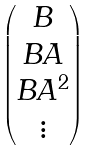Convert formula to latex. <formula><loc_0><loc_0><loc_500><loc_500>\begin{pmatrix} B \\ B A \\ B A ^ { 2 } \\ \vdots \end{pmatrix}</formula> 